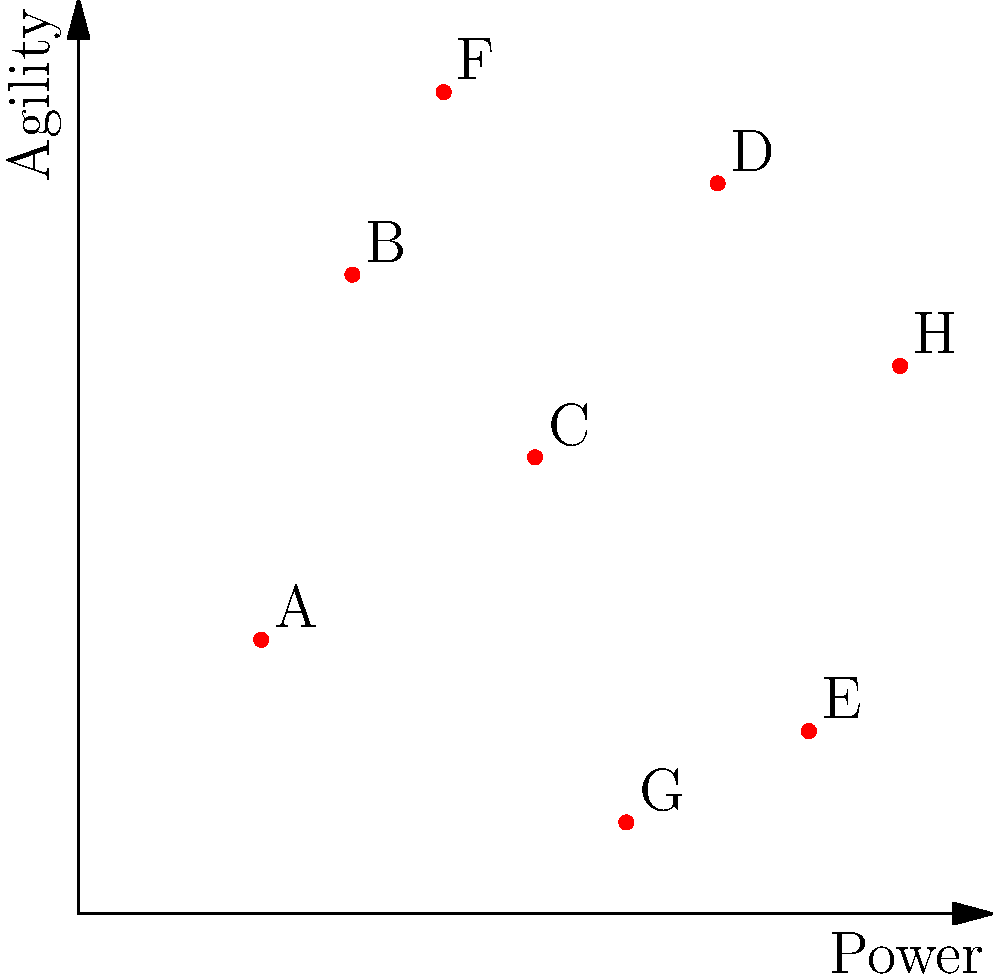Based on the 2D representation of squash players' game attributes (Power vs. Agility), which two players would most likely be clustered together in terms of playing style? To determine which two players would most likely be clustered together, we need to analyze their positions in the 2D space of Power vs. Agility. Players with similar attributes will be closer to each other in this representation. Let's follow these steps:

1. Observe the distribution of players in the graph.
2. Identify pairs of players that are closest to each other.
3. Compare the distances between these pairs.

Looking at the graph:

1. Players A and E are relatively close, both having low Agility but differing in Power.
2. Players B and H are close, with similar Power and Agility levels.
3. Players C and D are nearby, both having moderate to high levels of Power and Agility.
4. Players F and G are far apart from each other and other players.

Among these pairs, B and H appear to be the closest to each other in the 2D space. They have very similar Power levels (around 0.8-0.9) and comparable Agility levels (0.6-0.7). This suggests that their playing styles are likely to be the most similar among all the players represented.

The proximity of B and H in this 2D representation indicates that they would most likely be clustered together when analyzing playing styles based on Power and Agility attributes.
Answer: Players B and H 